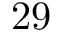Convert formula to latex. <formula><loc_0><loc_0><loc_500><loc_500>2 9</formula> 